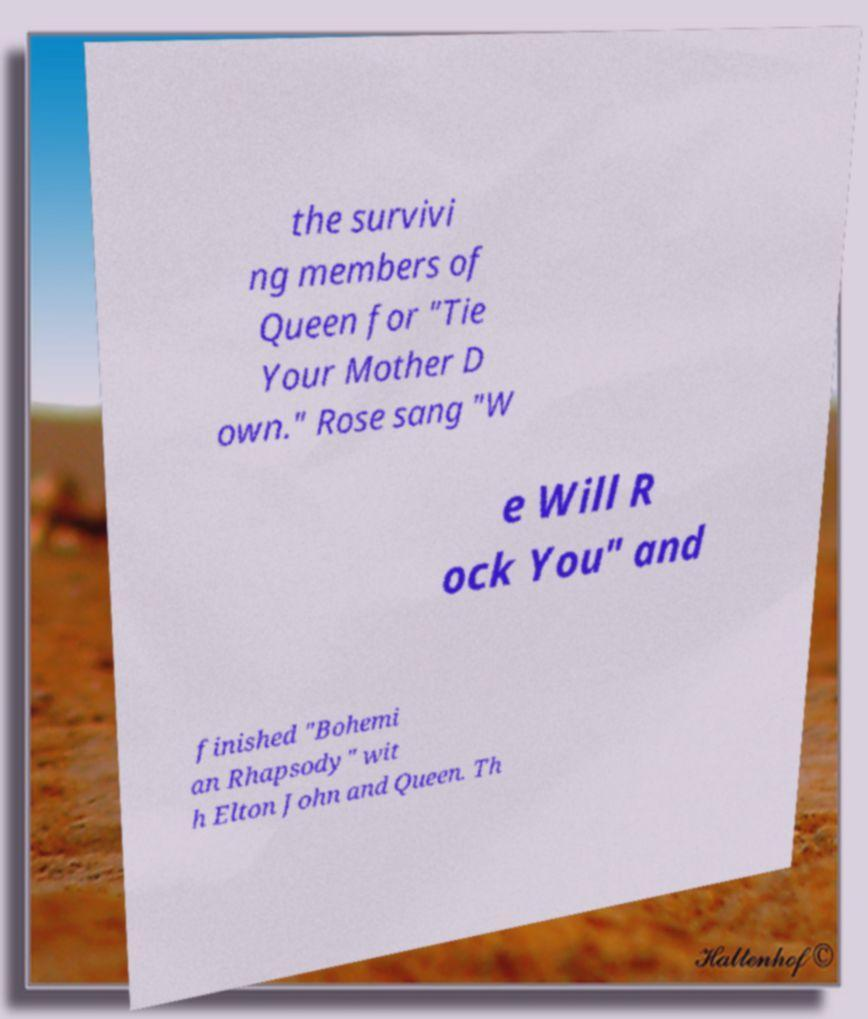Please identify and transcribe the text found in this image. the survivi ng members of Queen for "Tie Your Mother D own." Rose sang "W e Will R ock You" and finished "Bohemi an Rhapsody" wit h Elton John and Queen. Th 